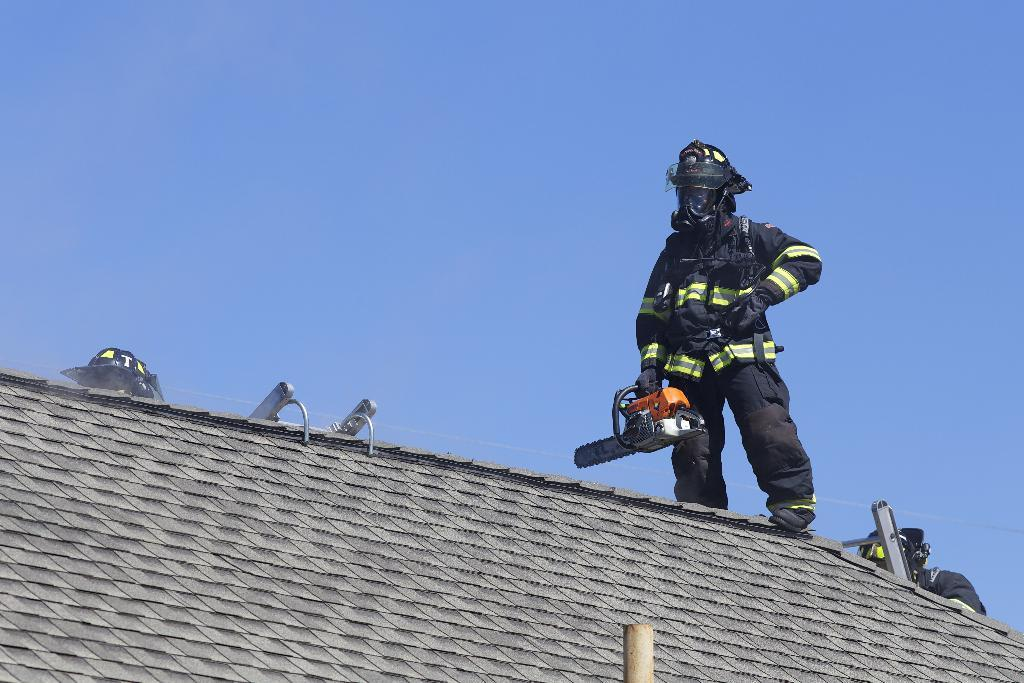Who is present in the image? There is a man in the image. Where is the man located? The man is standing on a rooftop. What is the man holding in the image? The man is holding something. What protective gear is the man wearing? The man is wearing a mask, gloves, and shoes. What can be seen in the sky at the top of the image? The sky is visible at the top of the image. What type of writer can be seen at the zoo in the image? There is no writer or zoo present in the image; it features a man standing on a rooftop. How does the man tie a knot with the object he is holding in the image? The man is not tying a knot in the image; he is simply holding something. 